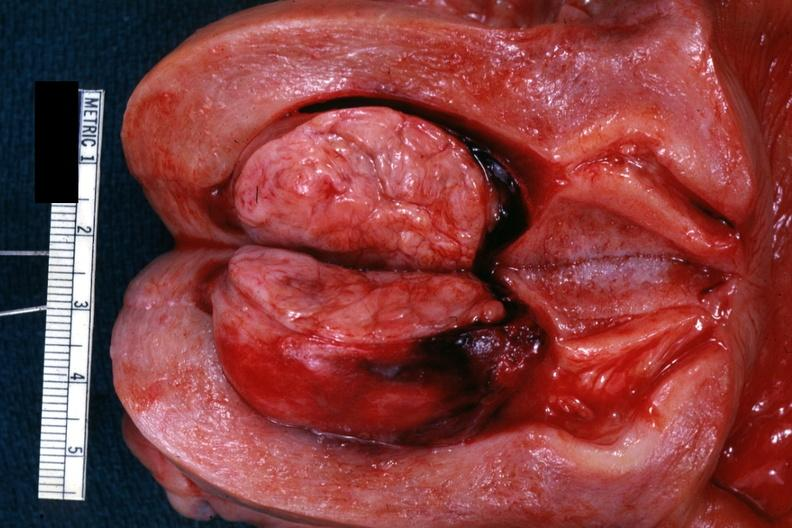does this image show excellent example of submucosal?
Answer the question using a single word or phrase. Yes 